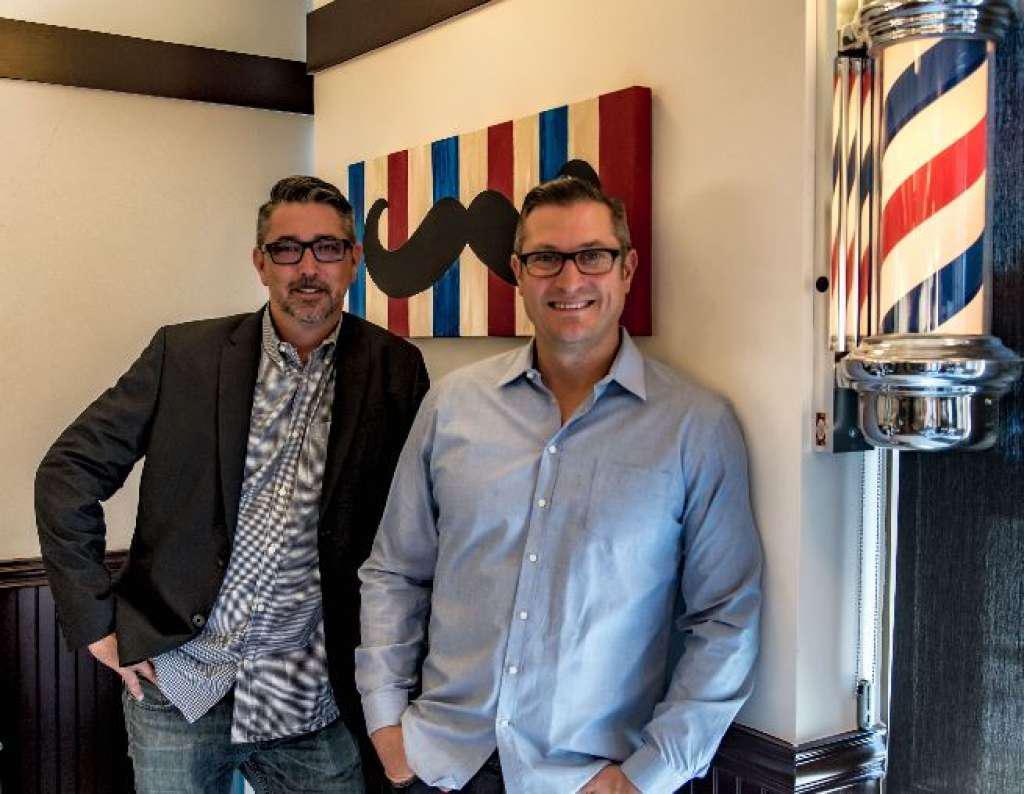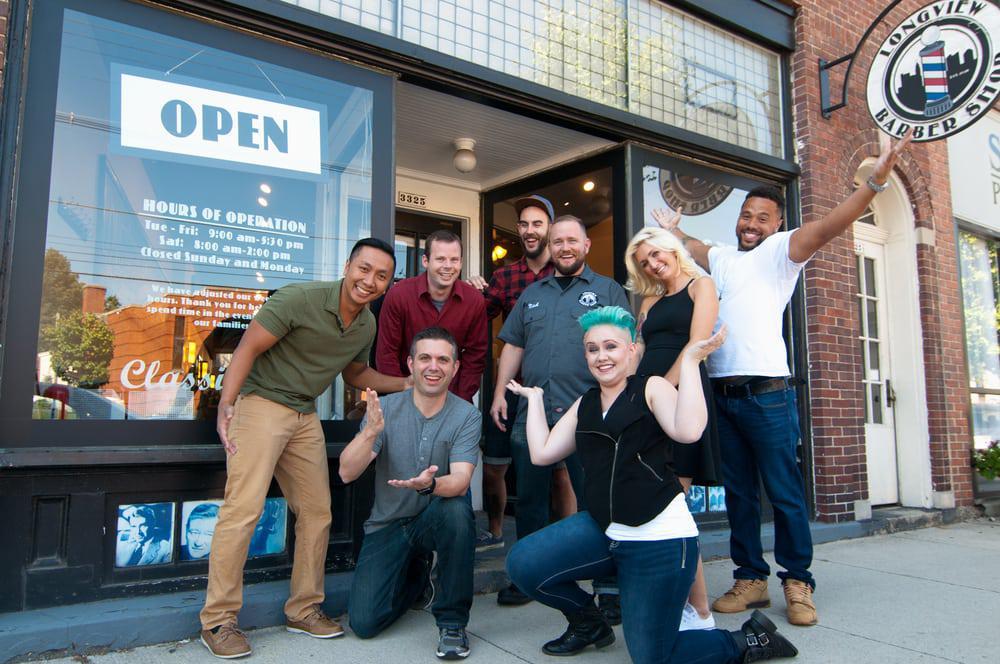The first image is the image on the left, the second image is the image on the right. Analyze the images presented: Is the assertion "One person is sitting in a barbers chair." valid? Answer yes or no. No. The first image is the image on the left, the second image is the image on the right. For the images displayed, is the sentence "In one of the images a male customer is being styled by a woman stylist." factually correct? Answer yes or no. No. 